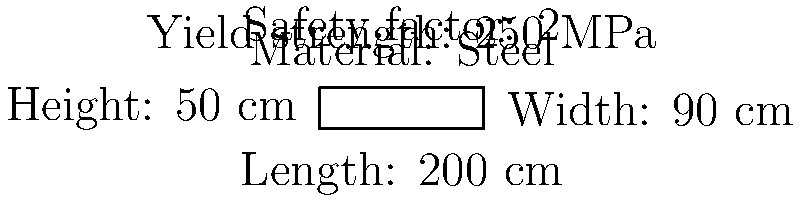As a nurse providing home care for an ailing parent, you need to ensure the safety of the hospital bed. Given the dimensions and material properties shown in the diagram, calculate the safe load capacity of the bed in kilograms (kg). Assume the bed frame is made of hollow square steel tubing with a cross-sectional area of 4 cm² and that the load is distributed evenly across the bed's surface. To calculate the safe load capacity of the hospital bed, we'll follow these steps:

1. Calculate the cross-sectional area of the bed frame:
   Given: Cross-sectional area = 4 cm² = 4 × 10⁻⁴ m²

2. Calculate the maximum allowable stress:
   Yield strength = 250 MPa
   Safety factor = 2
   Allowable stress = Yield strength ÷ Safety factor
   $\sigma_{allowable} = \frac{250 \text{ MPa}}{2} = 125 \text{ MPa}$

3. Calculate the maximum allowable force:
   $F_{max} = \sigma_{allowable} \times \text{Cross-sectional area}$
   $F_{max} = 125 \times 10^6 \text{ Pa} \times 4 \times 10^{-4} \text{ m}^2 = 50,000 \text{ N}$

4. Convert force to mass:
   $m = \frac{F}{g}$, where $g = 9.81 \text{ m/s}^2$
   $m = \frac{50,000 \text{ N}}{9.81 \text{ m/s}^2} \approx 5,096 \text{ kg}$

5. Round down to the nearest whole number for added safety:
   Safe load capacity = 5,096 kg

Therefore, the safe load capacity of the hospital bed is 5,096 kg.
Answer: 5,096 kg 